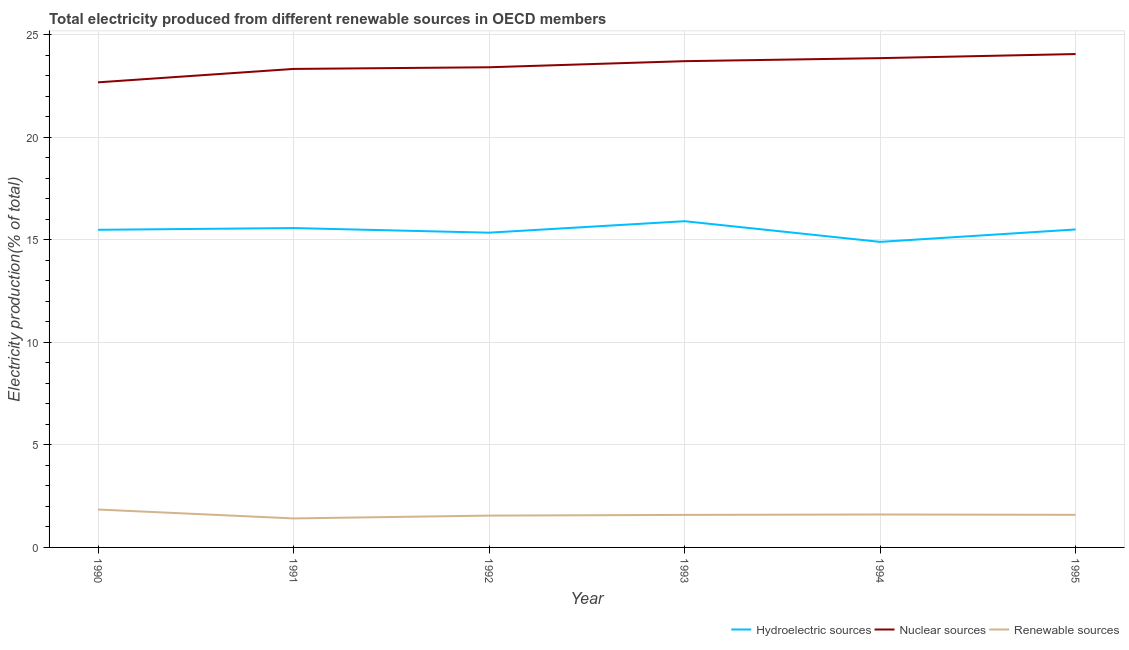How many different coloured lines are there?
Ensure brevity in your answer.  3. Does the line corresponding to percentage of electricity produced by hydroelectric sources intersect with the line corresponding to percentage of electricity produced by nuclear sources?
Offer a very short reply. No. Is the number of lines equal to the number of legend labels?
Keep it short and to the point. Yes. What is the percentage of electricity produced by hydroelectric sources in 1994?
Provide a short and direct response. 14.89. Across all years, what is the maximum percentage of electricity produced by nuclear sources?
Make the answer very short. 24.05. Across all years, what is the minimum percentage of electricity produced by hydroelectric sources?
Make the answer very short. 14.89. In which year was the percentage of electricity produced by hydroelectric sources maximum?
Make the answer very short. 1993. In which year was the percentage of electricity produced by hydroelectric sources minimum?
Offer a terse response. 1994. What is the total percentage of electricity produced by renewable sources in the graph?
Offer a very short reply. 9.59. What is the difference between the percentage of electricity produced by renewable sources in 1990 and that in 1995?
Offer a very short reply. 0.26. What is the difference between the percentage of electricity produced by hydroelectric sources in 1995 and the percentage of electricity produced by nuclear sources in 1992?
Offer a very short reply. -7.91. What is the average percentage of electricity produced by nuclear sources per year?
Offer a terse response. 23.5. In the year 1994, what is the difference between the percentage of electricity produced by renewable sources and percentage of electricity produced by nuclear sources?
Provide a short and direct response. -22.25. In how many years, is the percentage of electricity produced by hydroelectric sources greater than 13 %?
Your answer should be compact. 6. What is the ratio of the percentage of electricity produced by nuclear sources in 1991 to that in 1993?
Offer a very short reply. 0.98. Is the difference between the percentage of electricity produced by renewable sources in 1990 and 1993 greater than the difference between the percentage of electricity produced by nuclear sources in 1990 and 1993?
Your answer should be compact. Yes. What is the difference between the highest and the second highest percentage of electricity produced by hydroelectric sources?
Offer a terse response. 0.33. What is the difference between the highest and the lowest percentage of electricity produced by renewable sources?
Make the answer very short. 0.43. In how many years, is the percentage of electricity produced by nuclear sources greater than the average percentage of electricity produced by nuclear sources taken over all years?
Ensure brevity in your answer.  3. Is the percentage of electricity produced by nuclear sources strictly greater than the percentage of electricity produced by renewable sources over the years?
Your answer should be very brief. Yes. How many lines are there?
Keep it short and to the point. 3. How many years are there in the graph?
Provide a short and direct response. 6. Are the values on the major ticks of Y-axis written in scientific E-notation?
Keep it short and to the point. No. Does the graph contain any zero values?
Offer a very short reply. No. Where does the legend appear in the graph?
Your response must be concise. Bottom right. How are the legend labels stacked?
Make the answer very short. Horizontal. What is the title of the graph?
Give a very brief answer. Total electricity produced from different renewable sources in OECD members. Does "Ages 20-60" appear as one of the legend labels in the graph?
Provide a short and direct response. No. What is the label or title of the X-axis?
Provide a short and direct response. Year. What is the Electricity production(% of total) in Hydroelectric sources in 1990?
Your answer should be compact. 15.48. What is the Electricity production(% of total) of Nuclear sources in 1990?
Provide a succinct answer. 22.67. What is the Electricity production(% of total) in Renewable sources in 1990?
Ensure brevity in your answer.  1.85. What is the Electricity production(% of total) of Hydroelectric sources in 1991?
Your answer should be compact. 15.57. What is the Electricity production(% of total) of Nuclear sources in 1991?
Your answer should be compact. 23.32. What is the Electricity production(% of total) of Renewable sources in 1991?
Your response must be concise. 1.41. What is the Electricity production(% of total) in Hydroelectric sources in 1992?
Keep it short and to the point. 15.34. What is the Electricity production(% of total) in Nuclear sources in 1992?
Ensure brevity in your answer.  23.41. What is the Electricity production(% of total) of Renewable sources in 1992?
Provide a succinct answer. 1.55. What is the Electricity production(% of total) of Hydroelectric sources in 1993?
Provide a short and direct response. 15.9. What is the Electricity production(% of total) of Nuclear sources in 1993?
Provide a succinct answer. 23.7. What is the Electricity production(% of total) in Renewable sources in 1993?
Your response must be concise. 1.59. What is the Electricity production(% of total) of Hydroelectric sources in 1994?
Keep it short and to the point. 14.89. What is the Electricity production(% of total) of Nuclear sources in 1994?
Provide a succinct answer. 23.85. What is the Electricity production(% of total) in Renewable sources in 1994?
Keep it short and to the point. 1.61. What is the Electricity production(% of total) of Hydroelectric sources in 1995?
Keep it short and to the point. 15.5. What is the Electricity production(% of total) in Nuclear sources in 1995?
Offer a very short reply. 24.05. What is the Electricity production(% of total) in Renewable sources in 1995?
Keep it short and to the point. 1.59. Across all years, what is the maximum Electricity production(% of total) in Hydroelectric sources?
Keep it short and to the point. 15.9. Across all years, what is the maximum Electricity production(% of total) of Nuclear sources?
Offer a very short reply. 24.05. Across all years, what is the maximum Electricity production(% of total) of Renewable sources?
Your response must be concise. 1.85. Across all years, what is the minimum Electricity production(% of total) in Hydroelectric sources?
Your answer should be very brief. 14.89. Across all years, what is the minimum Electricity production(% of total) of Nuclear sources?
Your response must be concise. 22.67. Across all years, what is the minimum Electricity production(% of total) of Renewable sources?
Offer a very short reply. 1.41. What is the total Electricity production(% of total) in Hydroelectric sources in the graph?
Your answer should be very brief. 92.69. What is the total Electricity production(% of total) of Nuclear sources in the graph?
Make the answer very short. 141.01. What is the total Electricity production(% of total) of Renewable sources in the graph?
Provide a succinct answer. 9.59. What is the difference between the Electricity production(% of total) in Hydroelectric sources in 1990 and that in 1991?
Give a very brief answer. -0.08. What is the difference between the Electricity production(% of total) of Nuclear sources in 1990 and that in 1991?
Make the answer very short. -0.65. What is the difference between the Electricity production(% of total) of Renewable sources in 1990 and that in 1991?
Keep it short and to the point. 0.43. What is the difference between the Electricity production(% of total) of Hydroelectric sources in 1990 and that in 1992?
Make the answer very short. 0.14. What is the difference between the Electricity production(% of total) in Nuclear sources in 1990 and that in 1992?
Give a very brief answer. -0.73. What is the difference between the Electricity production(% of total) in Renewable sources in 1990 and that in 1992?
Offer a terse response. 0.3. What is the difference between the Electricity production(% of total) of Hydroelectric sources in 1990 and that in 1993?
Your answer should be compact. -0.42. What is the difference between the Electricity production(% of total) of Nuclear sources in 1990 and that in 1993?
Keep it short and to the point. -1.03. What is the difference between the Electricity production(% of total) of Renewable sources in 1990 and that in 1993?
Offer a very short reply. 0.26. What is the difference between the Electricity production(% of total) of Hydroelectric sources in 1990 and that in 1994?
Your answer should be very brief. 0.59. What is the difference between the Electricity production(% of total) of Nuclear sources in 1990 and that in 1994?
Offer a terse response. -1.18. What is the difference between the Electricity production(% of total) of Renewable sources in 1990 and that in 1994?
Ensure brevity in your answer.  0.24. What is the difference between the Electricity production(% of total) in Hydroelectric sources in 1990 and that in 1995?
Your answer should be compact. -0.02. What is the difference between the Electricity production(% of total) in Nuclear sources in 1990 and that in 1995?
Your answer should be compact. -1.38. What is the difference between the Electricity production(% of total) in Renewable sources in 1990 and that in 1995?
Provide a short and direct response. 0.26. What is the difference between the Electricity production(% of total) in Hydroelectric sources in 1991 and that in 1992?
Ensure brevity in your answer.  0.22. What is the difference between the Electricity production(% of total) of Nuclear sources in 1991 and that in 1992?
Provide a succinct answer. -0.08. What is the difference between the Electricity production(% of total) of Renewable sources in 1991 and that in 1992?
Ensure brevity in your answer.  -0.14. What is the difference between the Electricity production(% of total) of Hydroelectric sources in 1991 and that in 1993?
Your answer should be compact. -0.33. What is the difference between the Electricity production(% of total) in Nuclear sources in 1991 and that in 1993?
Your answer should be very brief. -0.38. What is the difference between the Electricity production(% of total) of Renewable sources in 1991 and that in 1993?
Offer a terse response. -0.17. What is the difference between the Electricity production(% of total) in Hydroelectric sources in 1991 and that in 1994?
Give a very brief answer. 0.67. What is the difference between the Electricity production(% of total) of Nuclear sources in 1991 and that in 1994?
Offer a terse response. -0.53. What is the difference between the Electricity production(% of total) of Renewable sources in 1991 and that in 1994?
Offer a very short reply. -0.19. What is the difference between the Electricity production(% of total) in Hydroelectric sources in 1991 and that in 1995?
Make the answer very short. 0.07. What is the difference between the Electricity production(% of total) of Nuclear sources in 1991 and that in 1995?
Make the answer very short. -0.73. What is the difference between the Electricity production(% of total) in Renewable sources in 1991 and that in 1995?
Provide a short and direct response. -0.17. What is the difference between the Electricity production(% of total) in Hydroelectric sources in 1992 and that in 1993?
Your answer should be very brief. -0.56. What is the difference between the Electricity production(% of total) in Nuclear sources in 1992 and that in 1993?
Your answer should be compact. -0.3. What is the difference between the Electricity production(% of total) in Renewable sources in 1992 and that in 1993?
Provide a short and direct response. -0.03. What is the difference between the Electricity production(% of total) in Hydroelectric sources in 1992 and that in 1994?
Provide a short and direct response. 0.45. What is the difference between the Electricity production(% of total) of Nuclear sources in 1992 and that in 1994?
Offer a very short reply. -0.45. What is the difference between the Electricity production(% of total) of Renewable sources in 1992 and that in 1994?
Your answer should be very brief. -0.05. What is the difference between the Electricity production(% of total) of Hydroelectric sources in 1992 and that in 1995?
Make the answer very short. -0.16. What is the difference between the Electricity production(% of total) of Nuclear sources in 1992 and that in 1995?
Offer a very short reply. -0.64. What is the difference between the Electricity production(% of total) in Renewable sources in 1992 and that in 1995?
Your answer should be very brief. -0.04. What is the difference between the Electricity production(% of total) in Hydroelectric sources in 1993 and that in 1994?
Provide a short and direct response. 1.01. What is the difference between the Electricity production(% of total) in Nuclear sources in 1993 and that in 1994?
Your response must be concise. -0.15. What is the difference between the Electricity production(% of total) of Renewable sources in 1993 and that in 1994?
Ensure brevity in your answer.  -0.02. What is the difference between the Electricity production(% of total) in Hydroelectric sources in 1993 and that in 1995?
Give a very brief answer. 0.4. What is the difference between the Electricity production(% of total) in Nuclear sources in 1993 and that in 1995?
Your answer should be compact. -0.35. What is the difference between the Electricity production(% of total) of Renewable sources in 1993 and that in 1995?
Offer a very short reply. -0. What is the difference between the Electricity production(% of total) of Hydroelectric sources in 1994 and that in 1995?
Give a very brief answer. -0.61. What is the difference between the Electricity production(% of total) of Nuclear sources in 1994 and that in 1995?
Provide a short and direct response. -0.2. What is the difference between the Electricity production(% of total) of Renewable sources in 1994 and that in 1995?
Keep it short and to the point. 0.02. What is the difference between the Electricity production(% of total) in Hydroelectric sources in 1990 and the Electricity production(% of total) in Nuclear sources in 1991?
Offer a very short reply. -7.84. What is the difference between the Electricity production(% of total) in Hydroelectric sources in 1990 and the Electricity production(% of total) in Renewable sources in 1991?
Keep it short and to the point. 14.07. What is the difference between the Electricity production(% of total) in Nuclear sources in 1990 and the Electricity production(% of total) in Renewable sources in 1991?
Give a very brief answer. 21.26. What is the difference between the Electricity production(% of total) in Hydroelectric sources in 1990 and the Electricity production(% of total) in Nuclear sources in 1992?
Offer a terse response. -7.92. What is the difference between the Electricity production(% of total) in Hydroelectric sources in 1990 and the Electricity production(% of total) in Renewable sources in 1992?
Keep it short and to the point. 13.93. What is the difference between the Electricity production(% of total) of Nuclear sources in 1990 and the Electricity production(% of total) of Renewable sources in 1992?
Offer a very short reply. 21.12. What is the difference between the Electricity production(% of total) of Hydroelectric sources in 1990 and the Electricity production(% of total) of Nuclear sources in 1993?
Give a very brief answer. -8.22. What is the difference between the Electricity production(% of total) of Hydroelectric sources in 1990 and the Electricity production(% of total) of Renewable sources in 1993?
Provide a short and direct response. 13.9. What is the difference between the Electricity production(% of total) of Nuclear sources in 1990 and the Electricity production(% of total) of Renewable sources in 1993?
Your answer should be compact. 21.09. What is the difference between the Electricity production(% of total) of Hydroelectric sources in 1990 and the Electricity production(% of total) of Nuclear sources in 1994?
Your response must be concise. -8.37. What is the difference between the Electricity production(% of total) of Hydroelectric sources in 1990 and the Electricity production(% of total) of Renewable sources in 1994?
Make the answer very short. 13.88. What is the difference between the Electricity production(% of total) of Nuclear sources in 1990 and the Electricity production(% of total) of Renewable sources in 1994?
Keep it short and to the point. 21.07. What is the difference between the Electricity production(% of total) in Hydroelectric sources in 1990 and the Electricity production(% of total) in Nuclear sources in 1995?
Ensure brevity in your answer.  -8.57. What is the difference between the Electricity production(% of total) in Hydroelectric sources in 1990 and the Electricity production(% of total) in Renewable sources in 1995?
Provide a short and direct response. 13.89. What is the difference between the Electricity production(% of total) of Nuclear sources in 1990 and the Electricity production(% of total) of Renewable sources in 1995?
Offer a very short reply. 21.08. What is the difference between the Electricity production(% of total) in Hydroelectric sources in 1991 and the Electricity production(% of total) in Nuclear sources in 1992?
Make the answer very short. -7.84. What is the difference between the Electricity production(% of total) in Hydroelectric sources in 1991 and the Electricity production(% of total) in Renewable sources in 1992?
Your answer should be compact. 14.02. What is the difference between the Electricity production(% of total) of Nuclear sources in 1991 and the Electricity production(% of total) of Renewable sources in 1992?
Offer a terse response. 21.77. What is the difference between the Electricity production(% of total) in Hydroelectric sources in 1991 and the Electricity production(% of total) in Nuclear sources in 1993?
Your answer should be very brief. -8.14. What is the difference between the Electricity production(% of total) in Hydroelectric sources in 1991 and the Electricity production(% of total) in Renewable sources in 1993?
Give a very brief answer. 13.98. What is the difference between the Electricity production(% of total) in Nuclear sources in 1991 and the Electricity production(% of total) in Renewable sources in 1993?
Keep it short and to the point. 21.74. What is the difference between the Electricity production(% of total) in Hydroelectric sources in 1991 and the Electricity production(% of total) in Nuclear sources in 1994?
Offer a terse response. -8.28. What is the difference between the Electricity production(% of total) in Hydroelectric sources in 1991 and the Electricity production(% of total) in Renewable sources in 1994?
Offer a very short reply. 13.96. What is the difference between the Electricity production(% of total) of Nuclear sources in 1991 and the Electricity production(% of total) of Renewable sources in 1994?
Your response must be concise. 21.72. What is the difference between the Electricity production(% of total) of Hydroelectric sources in 1991 and the Electricity production(% of total) of Nuclear sources in 1995?
Your answer should be compact. -8.48. What is the difference between the Electricity production(% of total) of Hydroelectric sources in 1991 and the Electricity production(% of total) of Renewable sources in 1995?
Ensure brevity in your answer.  13.98. What is the difference between the Electricity production(% of total) in Nuclear sources in 1991 and the Electricity production(% of total) in Renewable sources in 1995?
Ensure brevity in your answer.  21.74. What is the difference between the Electricity production(% of total) of Hydroelectric sources in 1992 and the Electricity production(% of total) of Nuclear sources in 1993?
Make the answer very short. -8.36. What is the difference between the Electricity production(% of total) of Hydroelectric sources in 1992 and the Electricity production(% of total) of Renewable sources in 1993?
Provide a short and direct response. 13.76. What is the difference between the Electricity production(% of total) of Nuclear sources in 1992 and the Electricity production(% of total) of Renewable sources in 1993?
Give a very brief answer. 21.82. What is the difference between the Electricity production(% of total) of Hydroelectric sources in 1992 and the Electricity production(% of total) of Nuclear sources in 1994?
Offer a terse response. -8.51. What is the difference between the Electricity production(% of total) in Hydroelectric sources in 1992 and the Electricity production(% of total) in Renewable sources in 1994?
Provide a short and direct response. 13.74. What is the difference between the Electricity production(% of total) of Nuclear sources in 1992 and the Electricity production(% of total) of Renewable sources in 1994?
Give a very brief answer. 21.8. What is the difference between the Electricity production(% of total) in Hydroelectric sources in 1992 and the Electricity production(% of total) in Nuclear sources in 1995?
Ensure brevity in your answer.  -8.71. What is the difference between the Electricity production(% of total) of Hydroelectric sources in 1992 and the Electricity production(% of total) of Renewable sources in 1995?
Your answer should be very brief. 13.75. What is the difference between the Electricity production(% of total) of Nuclear sources in 1992 and the Electricity production(% of total) of Renewable sources in 1995?
Make the answer very short. 21.82. What is the difference between the Electricity production(% of total) of Hydroelectric sources in 1993 and the Electricity production(% of total) of Nuclear sources in 1994?
Make the answer very short. -7.95. What is the difference between the Electricity production(% of total) in Hydroelectric sources in 1993 and the Electricity production(% of total) in Renewable sources in 1994?
Keep it short and to the point. 14.3. What is the difference between the Electricity production(% of total) in Nuclear sources in 1993 and the Electricity production(% of total) in Renewable sources in 1994?
Ensure brevity in your answer.  22.1. What is the difference between the Electricity production(% of total) in Hydroelectric sources in 1993 and the Electricity production(% of total) in Nuclear sources in 1995?
Your response must be concise. -8.15. What is the difference between the Electricity production(% of total) in Hydroelectric sources in 1993 and the Electricity production(% of total) in Renewable sources in 1995?
Ensure brevity in your answer.  14.31. What is the difference between the Electricity production(% of total) in Nuclear sources in 1993 and the Electricity production(% of total) in Renewable sources in 1995?
Your response must be concise. 22.11. What is the difference between the Electricity production(% of total) in Hydroelectric sources in 1994 and the Electricity production(% of total) in Nuclear sources in 1995?
Offer a terse response. -9.16. What is the difference between the Electricity production(% of total) in Hydroelectric sources in 1994 and the Electricity production(% of total) in Renewable sources in 1995?
Keep it short and to the point. 13.31. What is the difference between the Electricity production(% of total) in Nuclear sources in 1994 and the Electricity production(% of total) in Renewable sources in 1995?
Your answer should be compact. 22.26. What is the average Electricity production(% of total) of Hydroelectric sources per year?
Ensure brevity in your answer.  15.45. What is the average Electricity production(% of total) of Nuclear sources per year?
Provide a short and direct response. 23.5. What is the average Electricity production(% of total) of Renewable sources per year?
Your response must be concise. 1.6. In the year 1990, what is the difference between the Electricity production(% of total) of Hydroelectric sources and Electricity production(% of total) of Nuclear sources?
Make the answer very short. -7.19. In the year 1990, what is the difference between the Electricity production(% of total) of Hydroelectric sources and Electricity production(% of total) of Renewable sources?
Provide a short and direct response. 13.63. In the year 1990, what is the difference between the Electricity production(% of total) in Nuclear sources and Electricity production(% of total) in Renewable sources?
Provide a succinct answer. 20.82. In the year 1991, what is the difference between the Electricity production(% of total) of Hydroelectric sources and Electricity production(% of total) of Nuclear sources?
Your response must be concise. -7.76. In the year 1991, what is the difference between the Electricity production(% of total) in Hydroelectric sources and Electricity production(% of total) in Renewable sources?
Your answer should be very brief. 14.15. In the year 1991, what is the difference between the Electricity production(% of total) in Nuclear sources and Electricity production(% of total) in Renewable sources?
Give a very brief answer. 21.91. In the year 1992, what is the difference between the Electricity production(% of total) of Hydroelectric sources and Electricity production(% of total) of Nuclear sources?
Provide a short and direct response. -8.06. In the year 1992, what is the difference between the Electricity production(% of total) of Hydroelectric sources and Electricity production(% of total) of Renewable sources?
Provide a succinct answer. 13.79. In the year 1992, what is the difference between the Electricity production(% of total) of Nuclear sources and Electricity production(% of total) of Renewable sources?
Your answer should be compact. 21.85. In the year 1993, what is the difference between the Electricity production(% of total) of Hydroelectric sources and Electricity production(% of total) of Nuclear sources?
Offer a terse response. -7.8. In the year 1993, what is the difference between the Electricity production(% of total) of Hydroelectric sources and Electricity production(% of total) of Renewable sources?
Your answer should be very brief. 14.32. In the year 1993, what is the difference between the Electricity production(% of total) in Nuclear sources and Electricity production(% of total) in Renewable sources?
Keep it short and to the point. 22.12. In the year 1994, what is the difference between the Electricity production(% of total) of Hydroelectric sources and Electricity production(% of total) of Nuclear sources?
Your answer should be compact. -8.96. In the year 1994, what is the difference between the Electricity production(% of total) in Hydroelectric sources and Electricity production(% of total) in Renewable sources?
Provide a short and direct response. 13.29. In the year 1994, what is the difference between the Electricity production(% of total) of Nuclear sources and Electricity production(% of total) of Renewable sources?
Ensure brevity in your answer.  22.25. In the year 1995, what is the difference between the Electricity production(% of total) in Hydroelectric sources and Electricity production(% of total) in Nuclear sources?
Your answer should be very brief. -8.55. In the year 1995, what is the difference between the Electricity production(% of total) of Hydroelectric sources and Electricity production(% of total) of Renewable sources?
Ensure brevity in your answer.  13.91. In the year 1995, what is the difference between the Electricity production(% of total) of Nuclear sources and Electricity production(% of total) of Renewable sources?
Offer a very short reply. 22.46. What is the ratio of the Electricity production(% of total) of Hydroelectric sources in 1990 to that in 1991?
Your answer should be very brief. 0.99. What is the ratio of the Electricity production(% of total) of Nuclear sources in 1990 to that in 1991?
Your answer should be very brief. 0.97. What is the ratio of the Electricity production(% of total) of Renewable sources in 1990 to that in 1991?
Give a very brief answer. 1.31. What is the ratio of the Electricity production(% of total) of Hydroelectric sources in 1990 to that in 1992?
Your response must be concise. 1.01. What is the ratio of the Electricity production(% of total) in Nuclear sources in 1990 to that in 1992?
Keep it short and to the point. 0.97. What is the ratio of the Electricity production(% of total) in Renewable sources in 1990 to that in 1992?
Provide a succinct answer. 1.19. What is the ratio of the Electricity production(% of total) in Hydroelectric sources in 1990 to that in 1993?
Your response must be concise. 0.97. What is the ratio of the Electricity production(% of total) in Nuclear sources in 1990 to that in 1993?
Provide a short and direct response. 0.96. What is the ratio of the Electricity production(% of total) in Renewable sources in 1990 to that in 1993?
Keep it short and to the point. 1.17. What is the ratio of the Electricity production(% of total) of Hydroelectric sources in 1990 to that in 1994?
Offer a terse response. 1.04. What is the ratio of the Electricity production(% of total) of Nuclear sources in 1990 to that in 1994?
Your answer should be very brief. 0.95. What is the ratio of the Electricity production(% of total) in Renewable sources in 1990 to that in 1994?
Provide a short and direct response. 1.15. What is the ratio of the Electricity production(% of total) in Hydroelectric sources in 1990 to that in 1995?
Provide a short and direct response. 1. What is the ratio of the Electricity production(% of total) in Nuclear sources in 1990 to that in 1995?
Provide a succinct answer. 0.94. What is the ratio of the Electricity production(% of total) in Renewable sources in 1990 to that in 1995?
Offer a terse response. 1.16. What is the ratio of the Electricity production(% of total) in Hydroelectric sources in 1991 to that in 1992?
Keep it short and to the point. 1.01. What is the ratio of the Electricity production(% of total) of Renewable sources in 1991 to that in 1992?
Your response must be concise. 0.91. What is the ratio of the Electricity production(% of total) of Hydroelectric sources in 1991 to that in 1993?
Keep it short and to the point. 0.98. What is the ratio of the Electricity production(% of total) of Nuclear sources in 1991 to that in 1993?
Offer a very short reply. 0.98. What is the ratio of the Electricity production(% of total) in Renewable sources in 1991 to that in 1993?
Offer a terse response. 0.89. What is the ratio of the Electricity production(% of total) in Hydroelectric sources in 1991 to that in 1994?
Keep it short and to the point. 1.05. What is the ratio of the Electricity production(% of total) in Renewable sources in 1991 to that in 1994?
Provide a succinct answer. 0.88. What is the ratio of the Electricity production(% of total) of Nuclear sources in 1991 to that in 1995?
Provide a short and direct response. 0.97. What is the ratio of the Electricity production(% of total) of Renewable sources in 1991 to that in 1995?
Give a very brief answer. 0.89. What is the ratio of the Electricity production(% of total) of Hydroelectric sources in 1992 to that in 1993?
Provide a succinct answer. 0.96. What is the ratio of the Electricity production(% of total) in Nuclear sources in 1992 to that in 1993?
Your answer should be compact. 0.99. What is the ratio of the Electricity production(% of total) of Renewable sources in 1992 to that in 1993?
Offer a terse response. 0.98. What is the ratio of the Electricity production(% of total) of Hydroelectric sources in 1992 to that in 1994?
Your response must be concise. 1.03. What is the ratio of the Electricity production(% of total) in Nuclear sources in 1992 to that in 1994?
Offer a very short reply. 0.98. What is the ratio of the Electricity production(% of total) of Renewable sources in 1992 to that in 1994?
Offer a very short reply. 0.97. What is the ratio of the Electricity production(% of total) of Hydroelectric sources in 1992 to that in 1995?
Ensure brevity in your answer.  0.99. What is the ratio of the Electricity production(% of total) in Nuclear sources in 1992 to that in 1995?
Give a very brief answer. 0.97. What is the ratio of the Electricity production(% of total) of Renewable sources in 1992 to that in 1995?
Keep it short and to the point. 0.98. What is the ratio of the Electricity production(% of total) in Hydroelectric sources in 1993 to that in 1994?
Provide a short and direct response. 1.07. What is the ratio of the Electricity production(% of total) in Nuclear sources in 1993 to that in 1994?
Keep it short and to the point. 0.99. What is the ratio of the Electricity production(% of total) in Renewable sources in 1993 to that in 1994?
Give a very brief answer. 0.99. What is the ratio of the Electricity production(% of total) in Hydroelectric sources in 1993 to that in 1995?
Provide a short and direct response. 1.03. What is the ratio of the Electricity production(% of total) of Nuclear sources in 1993 to that in 1995?
Provide a succinct answer. 0.99. What is the ratio of the Electricity production(% of total) in Hydroelectric sources in 1994 to that in 1995?
Give a very brief answer. 0.96. What is the ratio of the Electricity production(% of total) of Nuclear sources in 1994 to that in 1995?
Offer a terse response. 0.99. What is the ratio of the Electricity production(% of total) in Renewable sources in 1994 to that in 1995?
Your answer should be very brief. 1.01. What is the difference between the highest and the second highest Electricity production(% of total) in Hydroelectric sources?
Offer a very short reply. 0.33. What is the difference between the highest and the second highest Electricity production(% of total) of Nuclear sources?
Give a very brief answer. 0.2. What is the difference between the highest and the second highest Electricity production(% of total) of Renewable sources?
Offer a very short reply. 0.24. What is the difference between the highest and the lowest Electricity production(% of total) of Hydroelectric sources?
Ensure brevity in your answer.  1.01. What is the difference between the highest and the lowest Electricity production(% of total) in Nuclear sources?
Give a very brief answer. 1.38. What is the difference between the highest and the lowest Electricity production(% of total) in Renewable sources?
Offer a terse response. 0.43. 